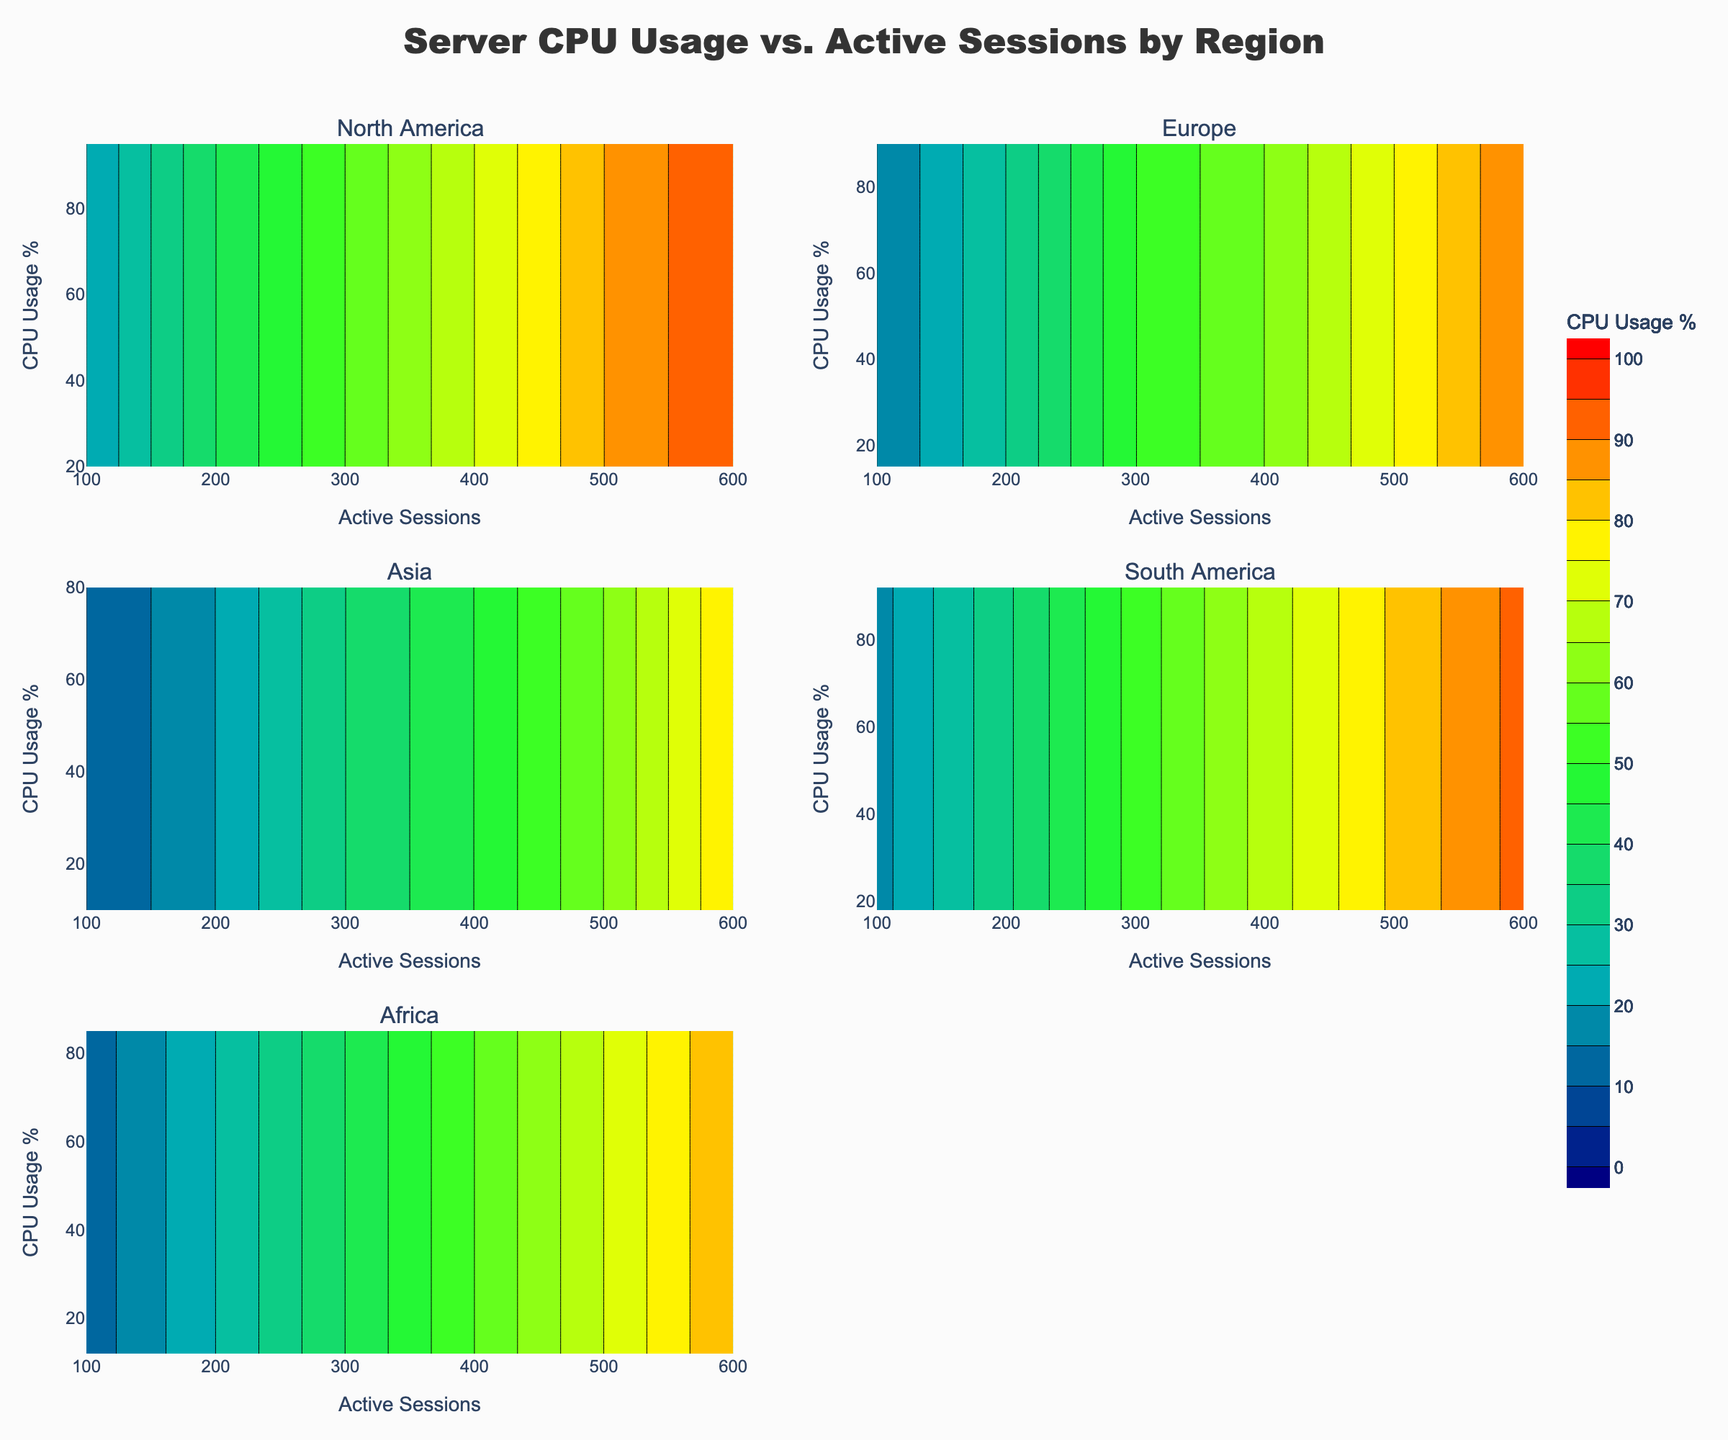What is the title of the figure? The title can be found at the top center of the figure. The text indicates the main theme of the figure.
Answer: Server CPU Usage vs. Active Sessions by Region Which region shows the highest CPU usage percentage for 600 active sessions? Locate the subplot for each region and identify the CPU usage percentage at 600 active sessions. The region with the highest value will have the highest CPU usage.
Answer: North America and South America For Europe, at what number of active sessions does the CPU usage reach 50%? Look at the Europe subplot and identify where the contour line for 50% intersects the x-axis representing active sessions.
Answer: 300 How does the CPU usage percentage in Asia compare between 100 and 500 active sessions? Observe the Asia subplot and compare the CPU usage percentages at 100 and 500 active sessions directly from the contour levels.
Answer: At 100 sessions: 10%, at 500 sessions: 60% Is there any region where the CPU usage percentage does not exceed 70%? Check each region's subplot to see if the contour lines reach or exceed 70%. If any region's highest contour line is less than 70%, note that region.
Answer: No In the subplot for Africa, what is the approximate CPU usage at 400 active sessions? In Africa's subplot, find the position of 400 active sessions on the x-axis and check the corresponding CPU usage percentage on the contour lines.
Answer: 55% What color represents the highest CPU usage percentage on the color scale? According to the color scale legend, identify the color associated with the highest value at the "100%" mark.
Answer: Red Which region has the lowest CPU usage percentage at 100 active sessions? Compare the CPU usage percentages at 100 active sessions across all regions to determine which one is the lowest.
Answer: Asia For North America, how does the CPU usage change between 200 and 400 active sessions? Examine North America's subplot and observe the CPU usage percentages for 200 and 400 active sessions to determine the change.
Answer: Increases from 40% to 70% Which region shows relatively faster growth in CPU usage percentage from 100 to 300 active sessions? By comparing the slopes or steepness of the contour lines from 100 to 300 active sessions in each region, identify the region with the steeper increase.
Answer: North America 